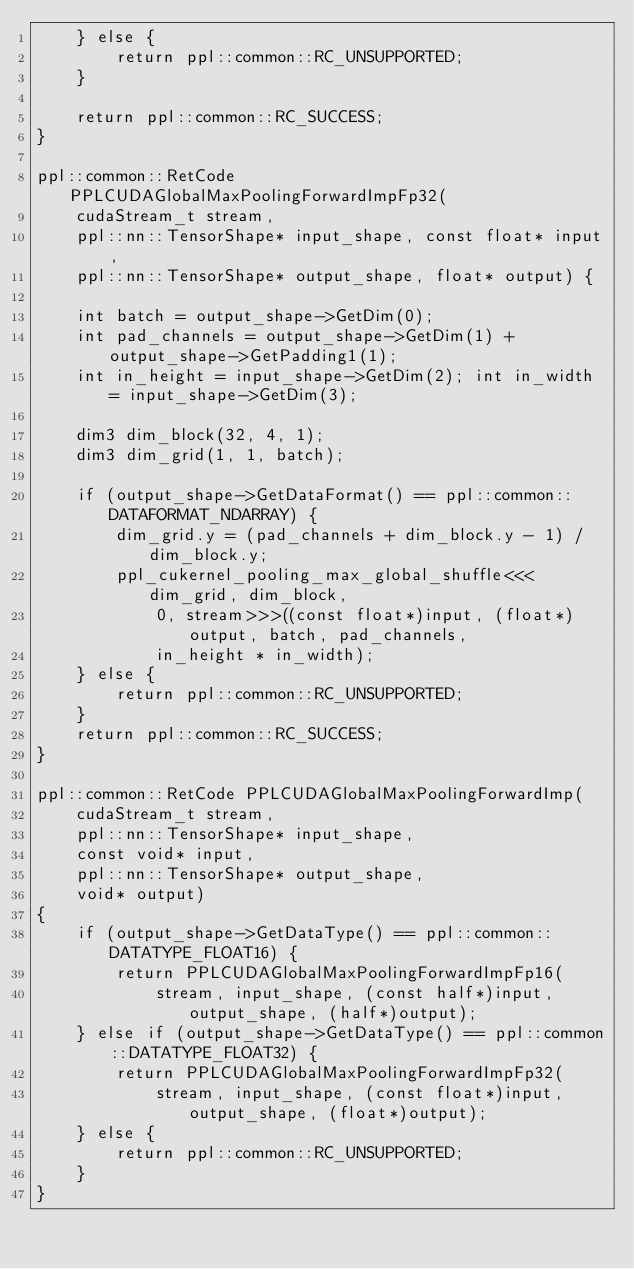<code> <loc_0><loc_0><loc_500><loc_500><_Cuda_>    } else {
        return ppl::common::RC_UNSUPPORTED;
    }

    return ppl::common::RC_SUCCESS;
}

ppl::common::RetCode PPLCUDAGlobalMaxPoolingForwardImpFp32(
    cudaStream_t stream,
    ppl::nn::TensorShape* input_shape, const float* input,
    ppl::nn::TensorShape* output_shape, float* output) {
    
    int batch = output_shape->GetDim(0);
    int pad_channels = output_shape->GetDim(1) + output_shape->GetPadding1(1);
    int in_height = input_shape->GetDim(2); int in_width = input_shape->GetDim(3);

    dim3 dim_block(32, 4, 1);
    dim3 dim_grid(1, 1, batch);

    if (output_shape->GetDataFormat() == ppl::common::DATAFORMAT_NDARRAY) {
        dim_grid.y = (pad_channels + dim_block.y - 1) / dim_block.y;
        ppl_cukernel_pooling_max_global_shuffle<<<dim_grid, dim_block,
            0, stream>>>((const float*)input, (float*)output, batch, pad_channels,
            in_height * in_width);
    } else {
        return ppl::common::RC_UNSUPPORTED;
    }
    return ppl::common::RC_SUCCESS;
}

ppl::common::RetCode PPLCUDAGlobalMaxPoolingForwardImp(
    cudaStream_t stream,
    ppl::nn::TensorShape* input_shape,
    const void* input,
    ppl::nn::TensorShape* output_shape,
    void* output)
{
    if (output_shape->GetDataType() == ppl::common::DATATYPE_FLOAT16) {
        return PPLCUDAGlobalMaxPoolingForwardImpFp16(
            stream, input_shape, (const half*)input, output_shape, (half*)output);
    } else if (output_shape->GetDataType() == ppl::common::DATATYPE_FLOAT32) {
        return PPLCUDAGlobalMaxPoolingForwardImpFp32(
            stream, input_shape, (const float*)input, output_shape, (float*)output);
    } else {
        return ppl::common::RC_UNSUPPORTED;
    }
}</code> 